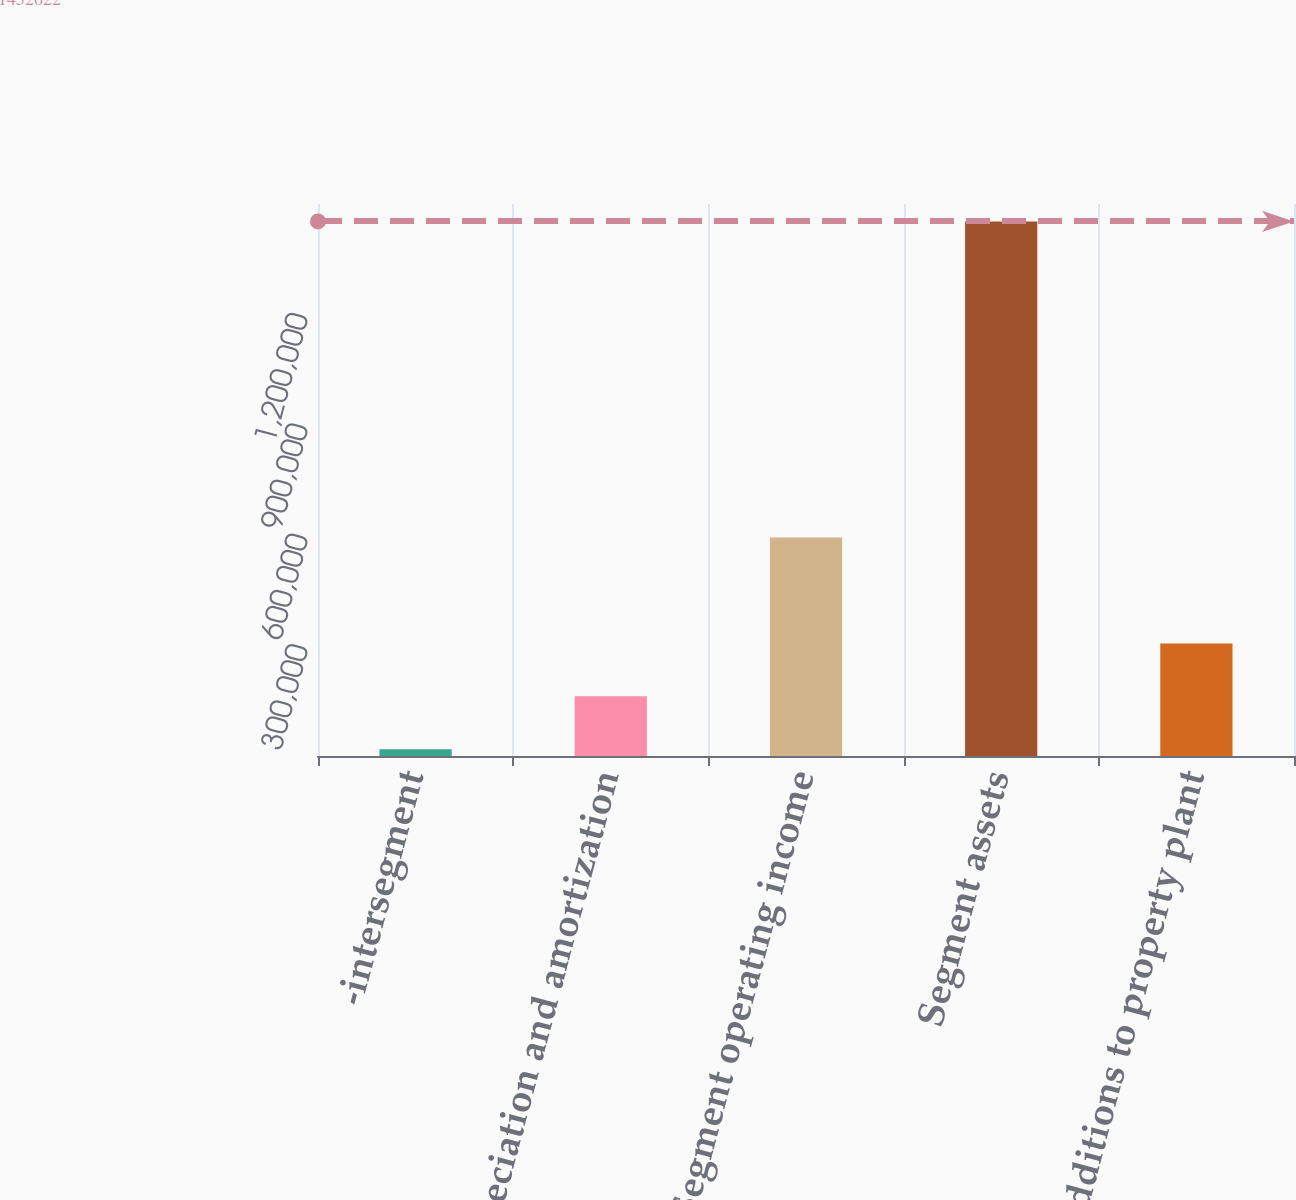Convert chart to OTSL. <chart><loc_0><loc_0><loc_500><loc_500><bar_chart><fcel>-intersegment<fcel>Depreciation and amortization<fcel>Segment operating income<fcel>Segment assets<fcel>Additions to property plant<nl><fcel>18681<fcel>162075<fcel>593510<fcel>1.45262e+06<fcel>305469<nl></chart> 